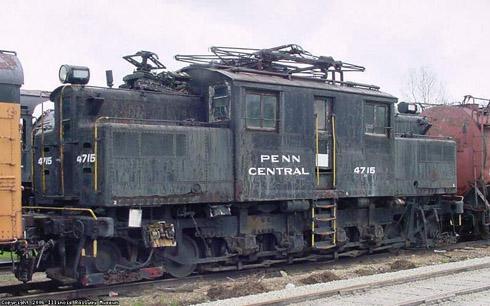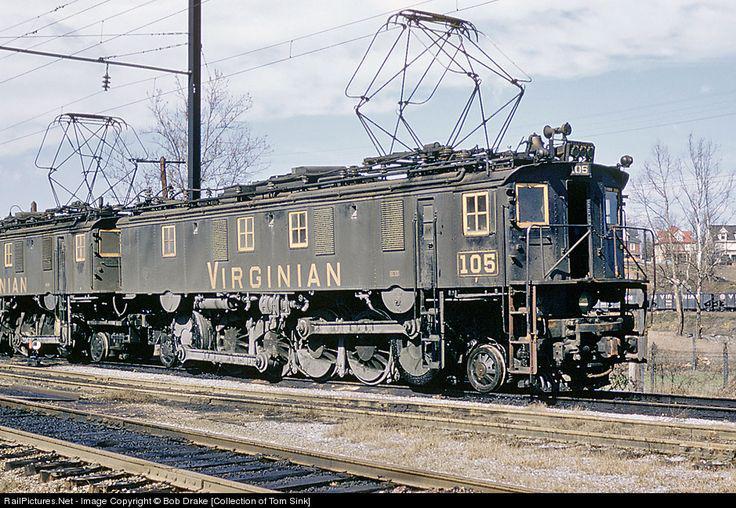The first image is the image on the left, the second image is the image on the right. Given the left and right images, does the statement "The right image includes at least one element with a pattern of bold diagonal lines near a red-orange train car." hold true? Answer yes or no. No. The first image is the image on the left, the second image is the image on the right. Examine the images to the left and right. Is the description "One train car is mostly orange, with diagonal stripes at it's nose." accurate? Answer yes or no. No. 